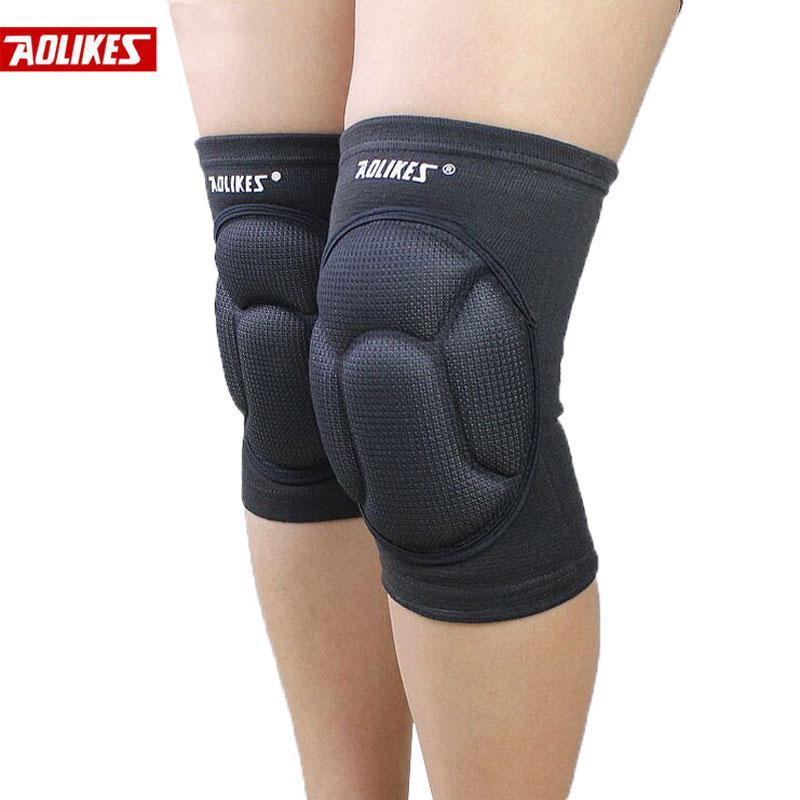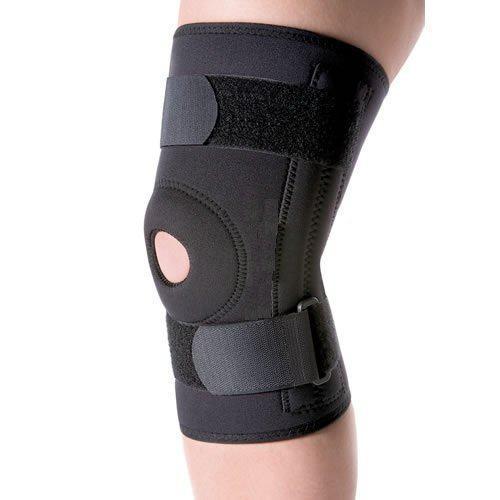The first image is the image on the left, the second image is the image on the right. Examine the images to the left and right. Is the description "All images featuring kneepads include human legs." accurate? Answer yes or no. Yes. 